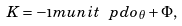<formula> <loc_0><loc_0><loc_500><loc_500>K = - \i m u n i t \ p d o _ { \theta } + \Phi ,</formula> 